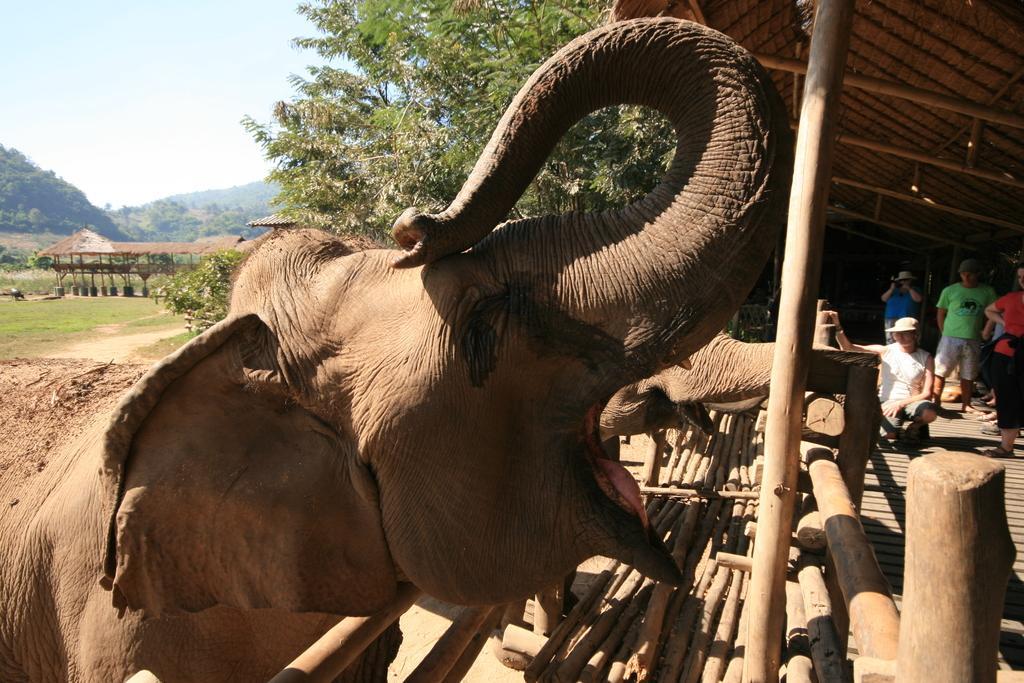How would you summarize this image in a sentence or two? In this image there is the sky towards the top of the image, there are trees, there is grass towards the left of the image, there is ground, there are wooden objects on the ground, there are elephants, there are persons standing towards the right of the image, there is a man taking a photo, there is roof towards the top of the image. 